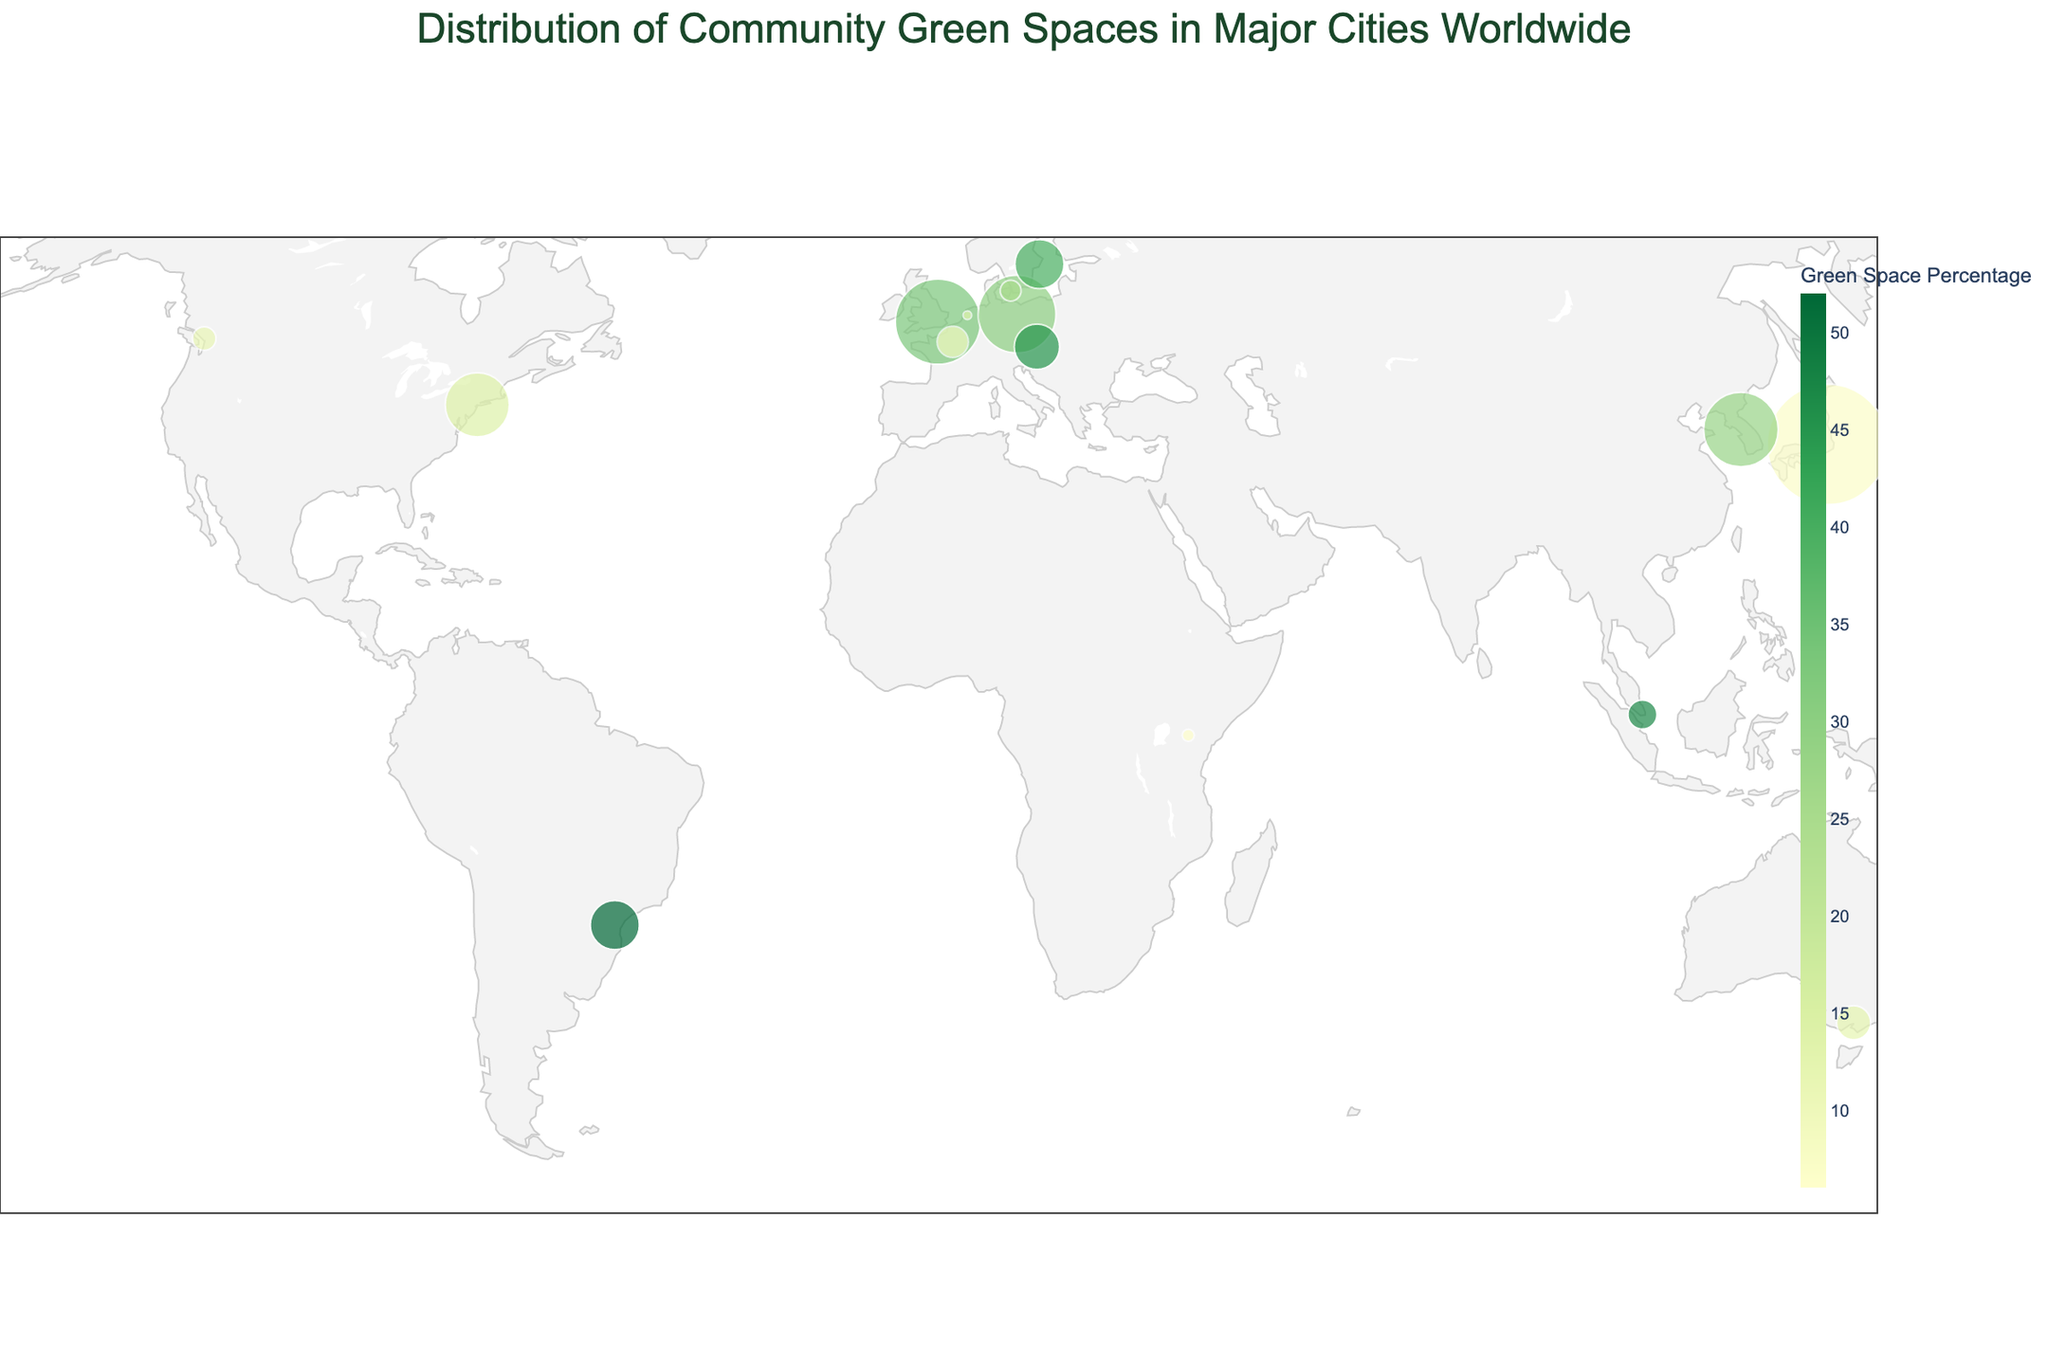Which city has the highest percentage of green space? By looking at the color and data in the plot, Singapore has the highest green space percentage with 47%.
Answer: Singapore Which city has the least number of parks? The size of the marker corresponding to Amsterdam is the smallest, indicating it has the least number of parks.
Answer: Amsterdam How many community gardens does Nairobi have? By hovering over the marker for Nairobi, the hover data shows it has 40 community gardens.
Answer: 40 Which city has more community gardens, Berlin or Vienna? By comparing the hover data over the markers for Berlin and Vienna, Berlin has 1000 community gardens while Vienna has 200.
Answer: Berlin What is the total number of parks in New York City and London combined? Hovering over New York City shows 1700 parks and London shows 3000 parks. Summing them up gives 1700 + 3000 = 4700.
Answer: 4700 What is the title of the figure? The title at the top of the plot reads "Distribution of Community Green Spaces in Major Cities Worldwide."
Answer: Distribution of Community Green Spaces in Major Cities Worldwide Rank the following cities by green space percentage from highest to lowest: Stockholm, Melbourne, Vancouver. By looking at the color and hover data for each city: Stockholm is 40%, Melbourne is 12%, and Vancouver is 11%.
Answer: Stockholm, Melbourne, Vancouver Which city has a similar green space percentage to Paris but a higher number of community gardens? Vienna has a similar green space percentage (45% compared to Paris's 9%) but a significantly higher number of community gardens (200 compared to Paris's 130).
Answer: Vienna What is the average number of community gardens for Tokyo, Copenhagen, and Seoul? By looking at the hover data: Tokyo has 80, Copenhagen has 75, and Seoul has 65. The average is (80 + 75 + 65) / 3 = 220 / 3 = 73.33.
Answer: 73.33 Which country has two cities listed in the plot, and what are they? By hovering over the markers, the country Germany has two cities listed: Berlin and Munich.
Answer: Germany, Berlin, Munich 